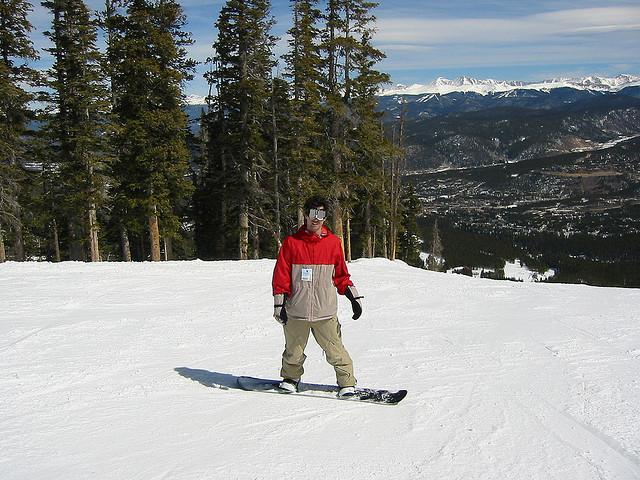What sport are they demonstrating?
Be succinct. Snowboarding. Are the trees leafless?
Be succinct. No. Is the man wearing goggles?
Write a very short answer. Yes. Is this a man?
Short answer required. Yes. Is there a lot of snow in the distance?
Write a very short answer. Yes. Is the man skiing?
Be succinct. No. What sport is this?
Write a very short answer. Snowboarding. 